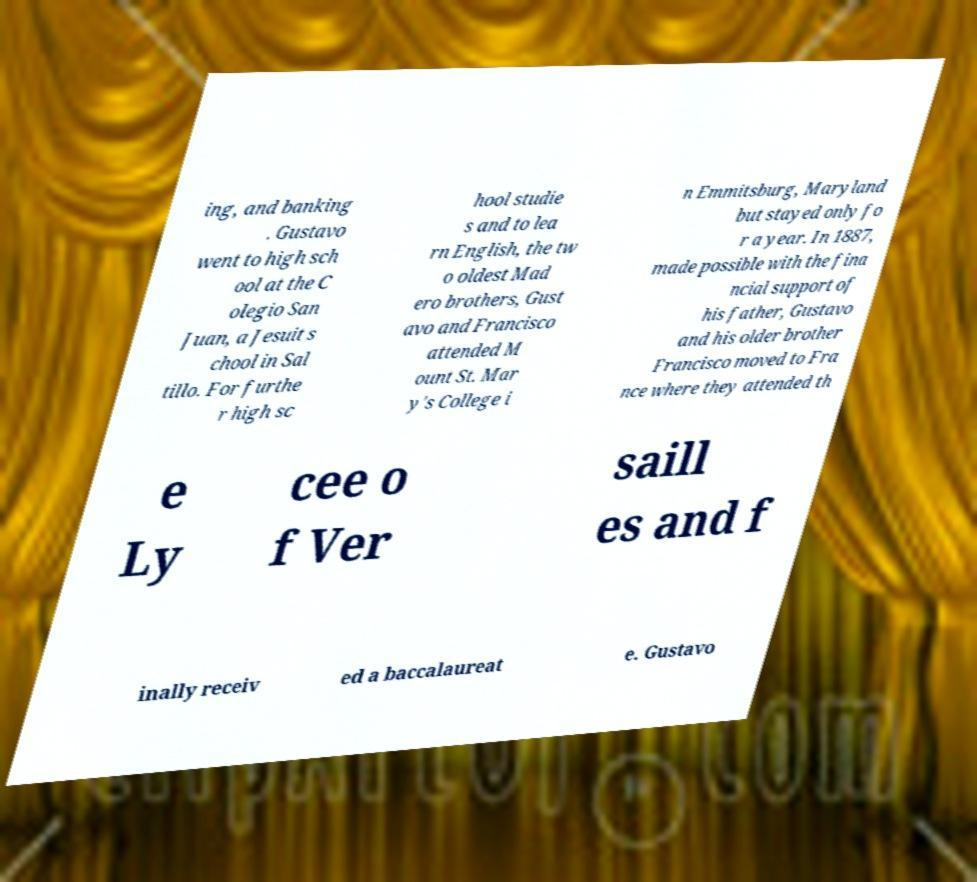I need the written content from this picture converted into text. Can you do that? ing, and banking . Gustavo went to high sch ool at the C olegio San Juan, a Jesuit s chool in Sal tillo. For furthe r high sc hool studie s and to lea rn English, the tw o oldest Mad ero brothers, Gust avo and Francisco attended M ount St. Mar y's College i n Emmitsburg, Maryland but stayed only fo r a year. In 1887, made possible with the fina ncial support of his father, Gustavo and his older brother Francisco moved to Fra nce where they attended th e Ly cee o f Ver saill es and f inally receiv ed a baccalaureat e. Gustavo 